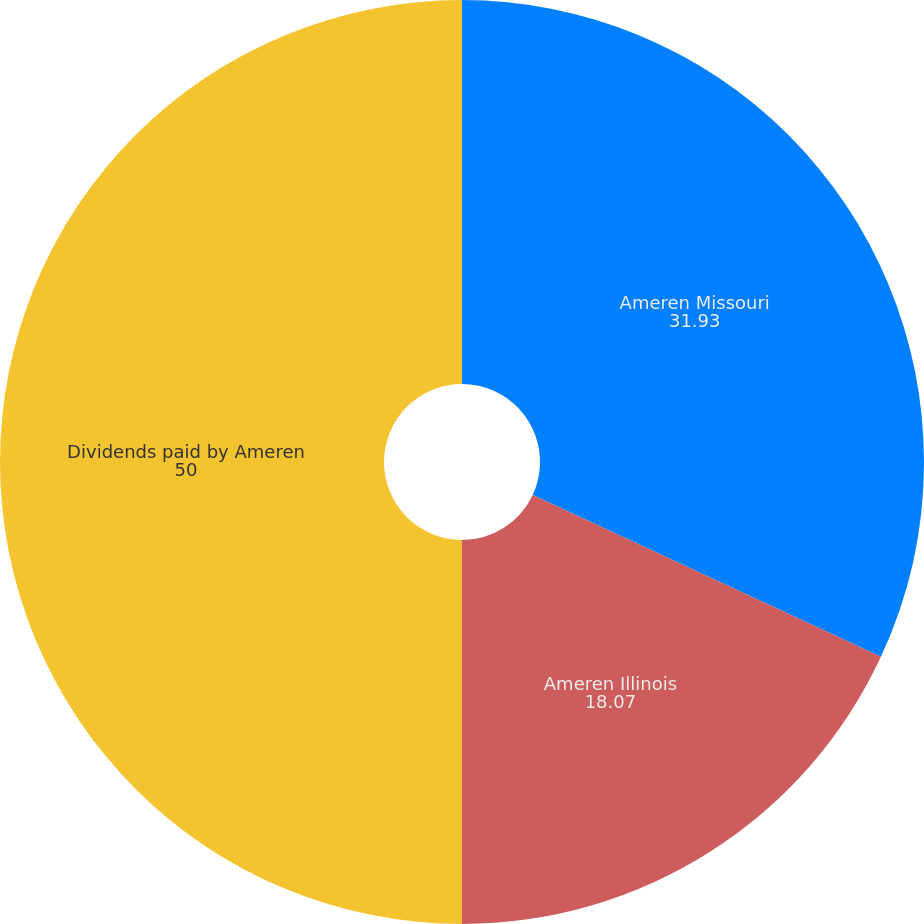Convert chart to OTSL. <chart><loc_0><loc_0><loc_500><loc_500><pie_chart><fcel>Ameren Missouri<fcel>Ameren Illinois<fcel>Dividends paid by Ameren<nl><fcel>31.93%<fcel>18.07%<fcel>50.0%<nl></chart> 